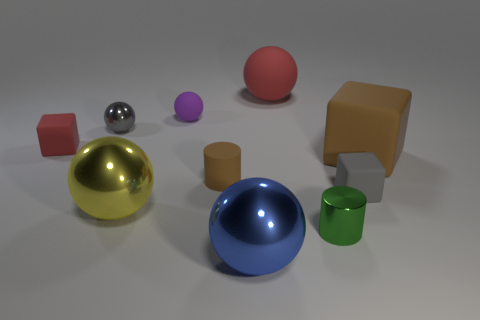Is the size of the gray rubber block the same as the red object behind the red cube?
Your response must be concise. No. Is the small purple rubber object the same shape as the large red rubber object?
Offer a terse response. Yes. Are there any small red rubber spheres?
Your answer should be compact. No. There is a purple rubber object; does it have the same shape as the big matte thing in front of the red matte block?
Ensure brevity in your answer.  No. What material is the large yellow object in front of the gray object that is in front of the brown cylinder?
Your answer should be very brief. Metal. The matte cylinder is what color?
Offer a very short reply. Brown. Is the color of the rubber cube that is on the left side of the green thing the same as the big ball behind the small gray block?
Offer a very short reply. Yes. The brown thing that is the same shape as the tiny gray rubber object is what size?
Provide a short and direct response. Large. Is there a tiny matte cylinder that has the same color as the big cube?
Offer a very short reply. Yes. What is the material of the cylinder that is the same color as the large rubber block?
Keep it short and to the point. Rubber. 